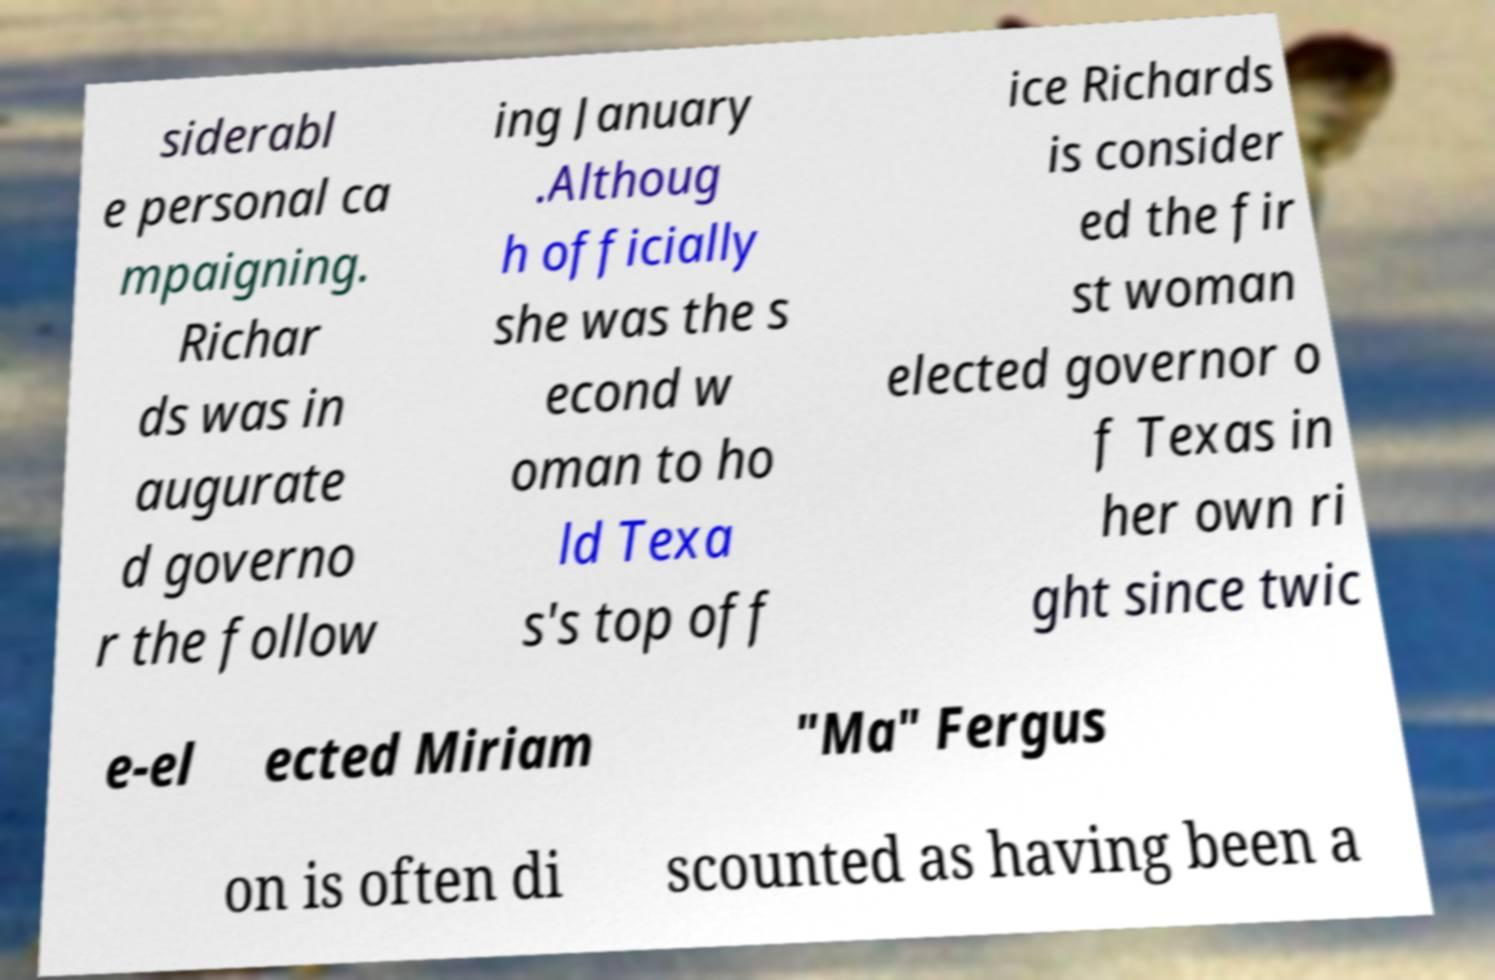Could you extract and type out the text from this image? siderabl e personal ca mpaigning. Richar ds was in augurate d governo r the follow ing January .Althoug h officially she was the s econd w oman to ho ld Texa s's top off ice Richards is consider ed the fir st woman elected governor o f Texas in her own ri ght since twic e-el ected Miriam "Ma" Fergus on is often di scounted as having been a 